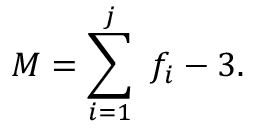Convert formula to latex. <formula><loc_0><loc_0><loc_500><loc_500>M = \sum _ { i = 1 } ^ { j } \ f _ { i } - 3 .</formula> 